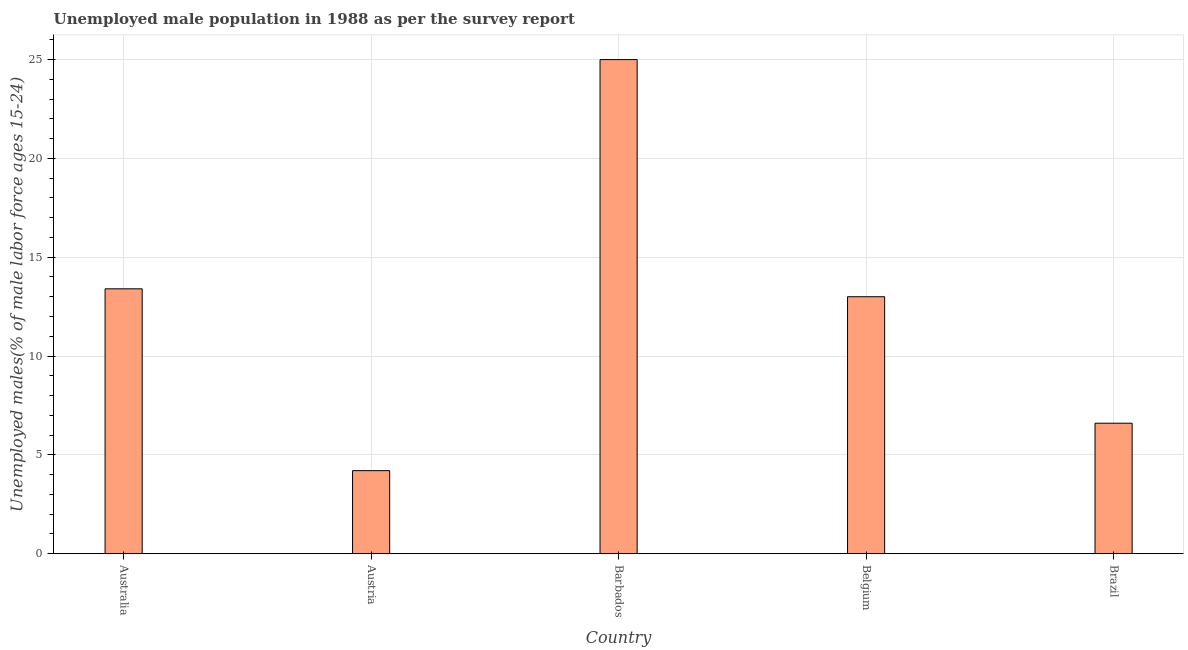What is the title of the graph?
Ensure brevity in your answer.  Unemployed male population in 1988 as per the survey report. What is the label or title of the X-axis?
Make the answer very short. Country. What is the label or title of the Y-axis?
Keep it short and to the point. Unemployed males(% of male labor force ages 15-24). What is the unemployed male youth in Barbados?
Your answer should be compact. 25. Across all countries, what is the minimum unemployed male youth?
Keep it short and to the point. 4.2. In which country was the unemployed male youth maximum?
Provide a succinct answer. Barbados. In which country was the unemployed male youth minimum?
Make the answer very short. Austria. What is the sum of the unemployed male youth?
Provide a succinct answer. 62.2. What is the average unemployed male youth per country?
Make the answer very short. 12.44. What is the median unemployed male youth?
Ensure brevity in your answer.  13. In how many countries, is the unemployed male youth greater than 10 %?
Offer a very short reply. 3. What is the ratio of the unemployed male youth in Barbados to that in Brazil?
Your answer should be very brief. 3.79. Is the difference between the unemployed male youth in Austria and Brazil greater than the difference between any two countries?
Provide a short and direct response. No. What is the difference between the highest and the lowest unemployed male youth?
Your answer should be compact. 20.8. What is the Unemployed males(% of male labor force ages 15-24) of Australia?
Provide a short and direct response. 13.4. What is the Unemployed males(% of male labor force ages 15-24) in Austria?
Keep it short and to the point. 4.2. What is the Unemployed males(% of male labor force ages 15-24) of Belgium?
Provide a succinct answer. 13. What is the Unemployed males(% of male labor force ages 15-24) in Brazil?
Offer a very short reply. 6.6. What is the difference between the Unemployed males(% of male labor force ages 15-24) in Australia and Austria?
Ensure brevity in your answer.  9.2. What is the difference between the Unemployed males(% of male labor force ages 15-24) in Australia and Belgium?
Make the answer very short. 0.4. What is the difference between the Unemployed males(% of male labor force ages 15-24) in Austria and Barbados?
Offer a terse response. -20.8. What is the difference between the Unemployed males(% of male labor force ages 15-24) in Austria and Belgium?
Your answer should be compact. -8.8. What is the difference between the Unemployed males(% of male labor force ages 15-24) in Belgium and Brazil?
Ensure brevity in your answer.  6.4. What is the ratio of the Unemployed males(% of male labor force ages 15-24) in Australia to that in Austria?
Give a very brief answer. 3.19. What is the ratio of the Unemployed males(% of male labor force ages 15-24) in Australia to that in Barbados?
Your answer should be compact. 0.54. What is the ratio of the Unemployed males(% of male labor force ages 15-24) in Australia to that in Belgium?
Your answer should be very brief. 1.03. What is the ratio of the Unemployed males(% of male labor force ages 15-24) in Australia to that in Brazil?
Your answer should be compact. 2.03. What is the ratio of the Unemployed males(% of male labor force ages 15-24) in Austria to that in Barbados?
Your answer should be compact. 0.17. What is the ratio of the Unemployed males(% of male labor force ages 15-24) in Austria to that in Belgium?
Provide a short and direct response. 0.32. What is the ratio of the Unemployed males(% of male labor force ages 15-24) in Austria to that in Brazil?
Keep it short and to the point. 0.64. What is the ratio of the Unemployed males(% of male labor force ages 15-24) in Barbados to that in Belgium?
Provide a short and direct response. 1.92. What is the ratio of the Unemployed males(% of male labor force ages 15-24) in Barbados to that in Brazil?
Offer a terse response. 3.79. What is the ratio of the Unemployed males(% of male labor force ages 15-24) in Belgium to that in Brazil?
Make the answer very short. 1.97. 